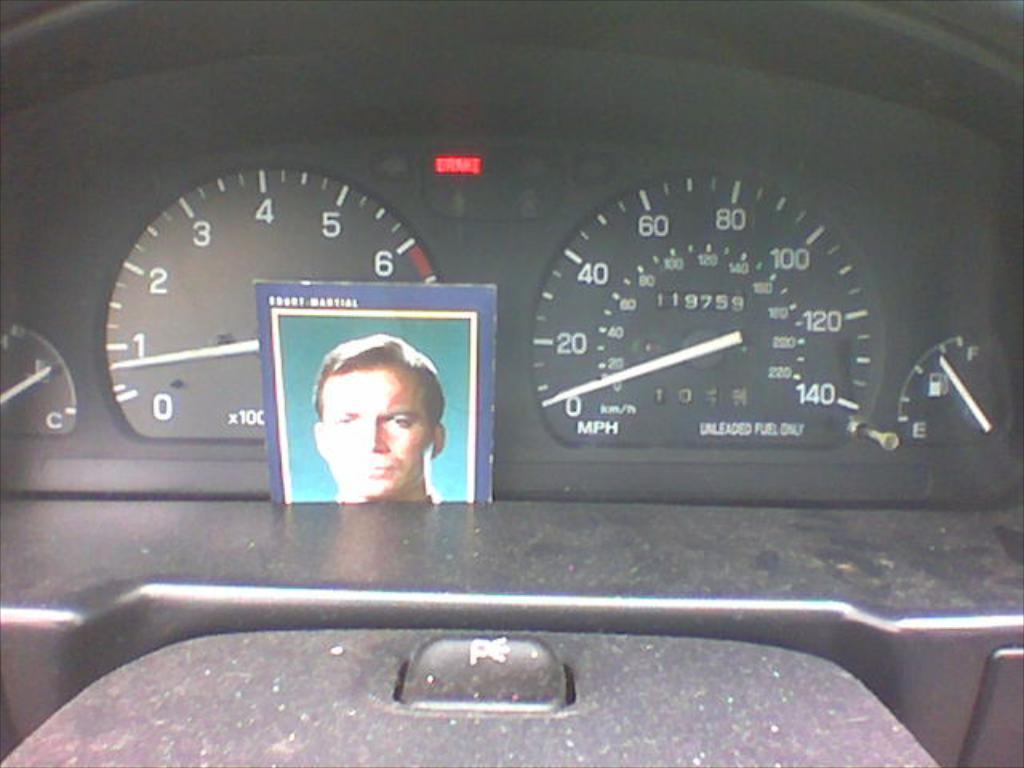What is the main subject of the image? The main subject of the image is a vehicle. What specific feature can be seen in the center of the image? There are speedometers in the center of the image. Is there any other object or element in the image besides the vehicle and speedometers? Yes, there is a photo in the image. What language is spoken by the rock in the image? There is no rock present in the image, and therefore no language can be attributed to it. 